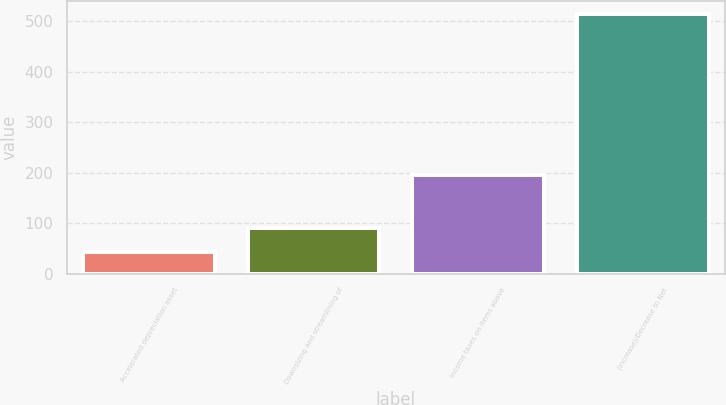Convert chart to OTSL. <chart><loc_0><loc_0><loc_500><loc_500><bar_chart><fcel>Accelerated depreciation asset<fcel>Downsizing and streamlining of<fcel>Income taxes on items above<fcel>(Increase)/Decrease to Net<nl><fcel>43<fcel>90.1<fcel>196<fcel>514<nl></chart> 